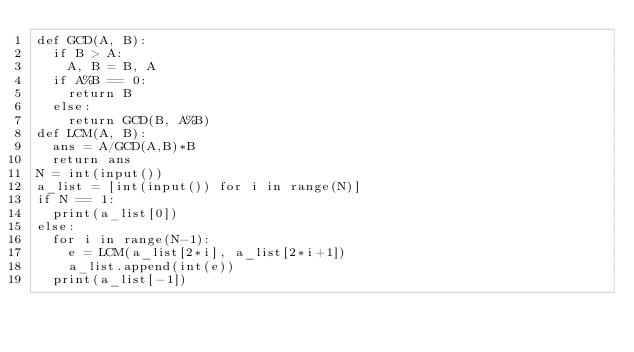<code> <loc_0><loc_0><loc_500><loc_500><_Python_>def GCD(A, B):
	if B > A:
		A, B = B, A
	if A%B == 0:
		return B
	else:
		return GCD(B, A%B)
def LCM(A, B):
	ans = A/GCD(A,B)*B
	return ans
N = int(input())
a_list = [int(input()) for i in range(N)]
if N == 1:
	print(a_list[0])
else:
	for i in range(N-1):
		e = LCM(a_list[2*i], a_list[2*i+1])
		a_list.append(int(e))
	print(a_list[-1])</code> 